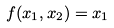Convert formula to latex. <formula><loc_0><loc_0><loc_500><loc_500>f ( x _ { 1 } , x _ { 2 } ) = x _ { 1 }</formula> 